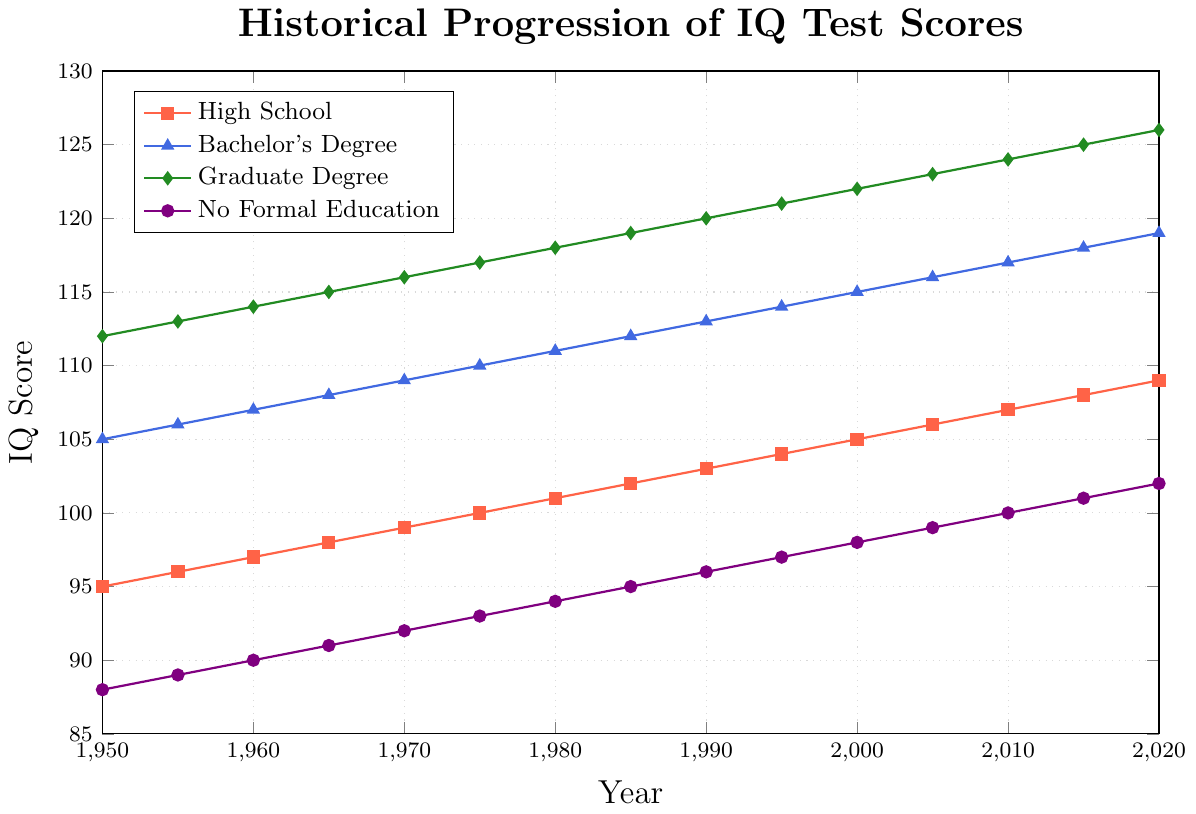What's the average IQ score for individuals with a Bachelor's Degree in 2020? The IQ score for individuals with a Bachelor's Degree in 2020 is 119. Since we're only looking at this specific year and group, the average is simply that value.
Answer: 119 How much did the IQ score for individuals with No Formal Education increase from 1950 to 2020? In 1950, the IQ score for individuals with No Formal Education was 88. By 2020, it was 102. Calculate the difference: 102 - 88 = 14.
Answer: 14 Which educational background had the steepest increase in IQ scores between 1950 and 2020? To see which group had the steepest increase, we need to compare the differences in IQ scores for each group over time. High School increased from 95 to 109 (14 points), Bachelor's Degree from 105 to 119 (14 points), Graduate Degree from 112 to 126 (14 points), and No Formal Education from 88 to 102 (14 points). Since they all had the same increase of 14 points, they all had equally steep increases.
Answer: All groups What was the difference in IQ scores between High School and Graduate Degree holders in 1975? In 1975, High School IQ scores were 100, and Graduate Degree IQ scores were 117. Calculate the difference: 117 - 100 = 17.
Answer: 17 Between which consecutive years did Bachelor's Degree holders experience the highest increase in IQ scores? We check the increments for each 5-year period: 1950-1955 (1), 1955-1960 (1), 1960-1965 (1), 1965-1970 (1), 1970-1975 (1), 1975-1980 (1), 1980-1985 (1), 1985-1990 (1), 1990-1995 (1), 1995-2000 (1), 2000-2005 (1), 2005-2010 (1), 2010-2015 (1), 2015-2020 (1). Each period shows an increase of 1 point. Therefore, there is no single period with a higher increase.
Answer: None By how many points did the IQ score for Graduate Degree holders change between 1980 and 2000? Graduate Degree holders had an IQ of 118 in 1980 and 122 in 2000. The change is calculated as 122 - 118 = 4.
Answer: 4 In what year did individuals with No Formal Education reach an average IQ score of 100? Looking at the progression, individuals with No Formal Education reached an IQ score of 100 in the year 2010.
Answer: 2010 Which educational group had the highest IQ score in 1950, and what was the score? In 1950, the highest IQ score was for individuals with a Graduate Degree, with a score of 112.
Answer: Graduate Degree, 112 By how many points did the average IQ score of High School graduates increase from 1975 to 2020? High School graduates had an IQ score of 100 in 1975 and 109 in 2020. Calculate the difference: 109 - 100 = 9.
Answer: 9 